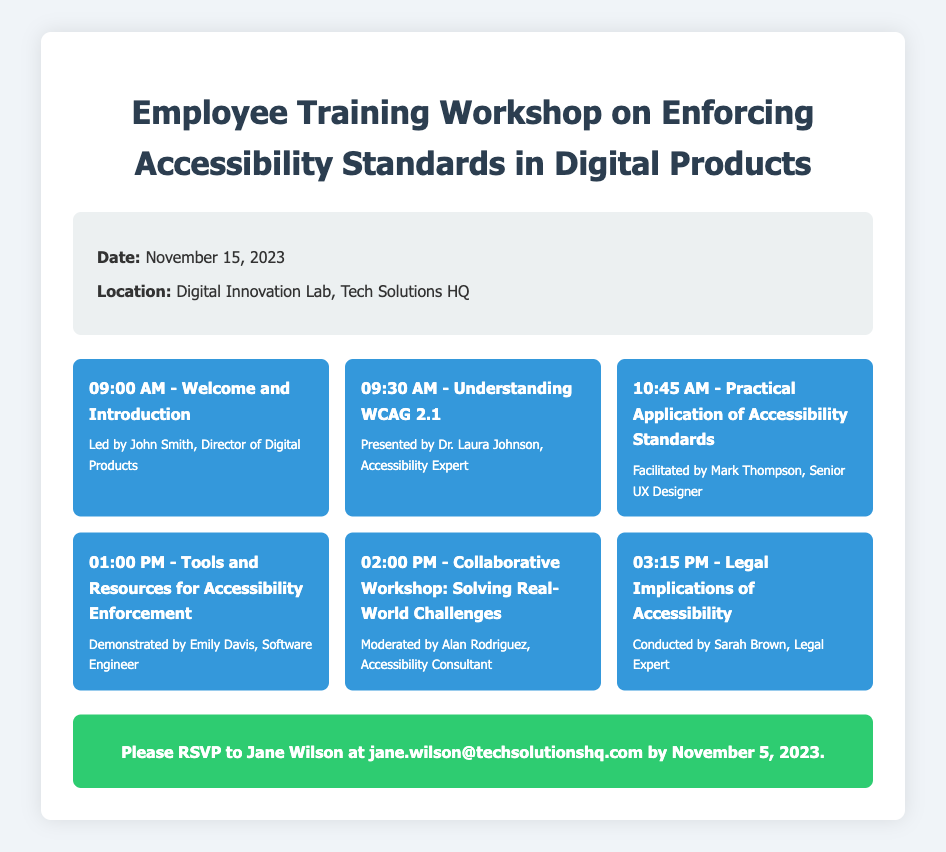What is the date of the workshop? The document states that the workshop is scheduled for November 15, 2023.
Answer: November 15, 2023 Where will the workshop be held? According to the document, the location of the workshop is the Digital Innovation Lab, Tech Solutions HQ.
Answer: Digital Innovation Lab, Tech Solutions HQ Who is facilitating the session on practical applications of accessibility standards? The document lists Mark Thompson as the facilitator for this session.
Answer: Mark Thompson What time does the collaborative workshop start? The schedule in the document indicates that the collaborative workshop starts at 02:00 PM.
Answer: 02:00 PM Who should RSVP to the workshop? Jane Wilson's name is mentioned in the RSVP section as the person to contact.
Answer: Jane Wilson What is the deadline for RSVPs? The document specifies that RSVPs should be submitted by November 5, 2023.
Answer: November 5, 2023 Which session discusses the legal implications of accessibility? The document indicates that the legal implications of accessibility are covered in a session conducted by Sarah Brown.
Answer: Sarah Brown What is the main focus of the session led by Dr. Laura Johnson? The document states that Dr. Laura Johnson's session is about understanding WCAG 2.1.
Answer: Understanding WCAG 2.1 What is the main purpose of the workshop? The title of the document suggests that the primary focus is on enforcing accessibility standards in digital products.
Answer: Enforcing accessibility standards in digital products 